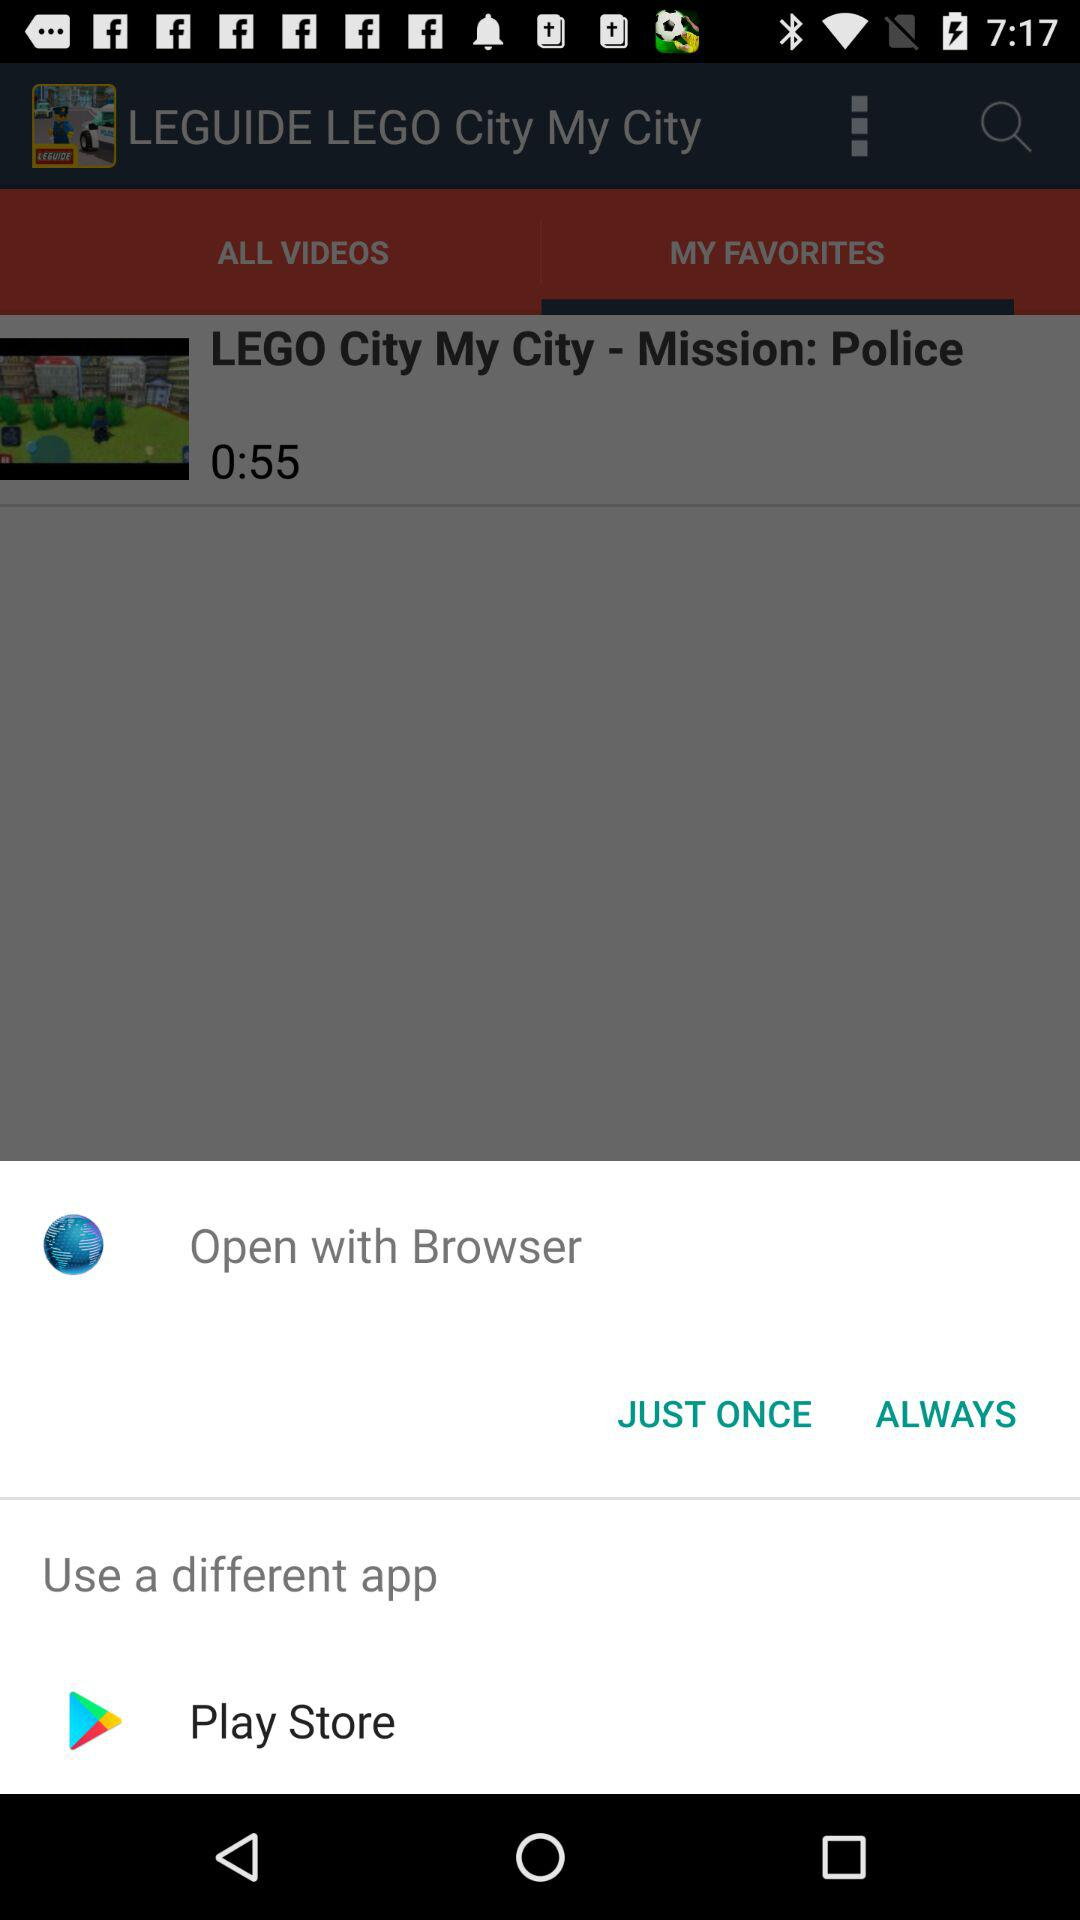What different application can we use? The different application that you can use is "Play Store". 